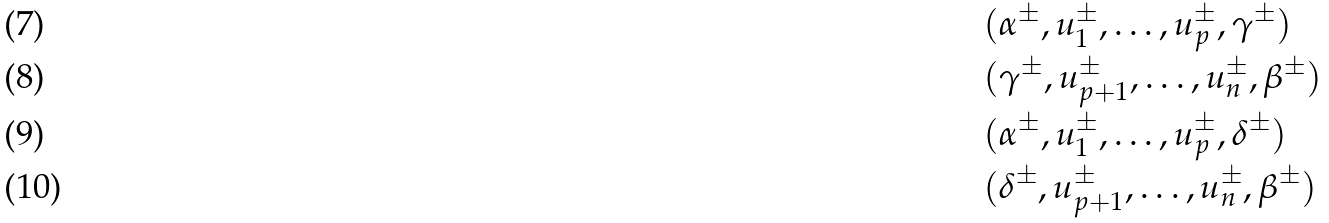<formula> <loc_0><loc_0><loc_500><loc_500>& ( \alpha ^ { \pm } , u _ { 1 } ^ { \pm } , \dots , u _ { p } ^ { \pm } , \gamma ^ { \pm } ) \\ & ( \gamma ^ { \pm } , u _ { p + 1 } ^ { \pm } , \dots , u _ { n } ^ { \pm } , \beta ^ { \pm } ) \\ & ( \alpha ^ { \pm } , u _ { 1 } ^ { \pm } , \dots , u _ { p } ^ { \pm } , \delta ^ { \pm } ) \\ & ( \delta ^ { \pm } , u _ { p + 1 } ^ { \pm } , \dots , u _ { n } ^ { \pm } , \beta ^ { \pm } )</formula> 